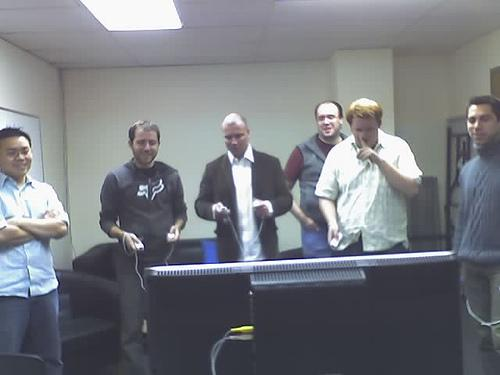Question: how many women are in the picture?
Choices:
A. None.
B. One.
C. Two.
D. Three.
Answer with the letter. Answer: A Question: what are the guys in the picture looking at?
Choices:
A. The women.
B. The food.
C. The TV screen.
D. The beer.
Answer with the letter. Answer: C Question: where was this picture taken?
Choices:
A. A pool hall.
B. On a back porch.
C. On a deck.
D. An indoor room.
Answer with the letter. Answer: D Question: why are they smiling?
Choices:
A. They are telling jokes.
B. They are jumping on a trampoline.
C. They are playing a game.
D. They are playing tag.
Answer with the letter. Answer: C Question: how many people are in the picture?
Choices:
A. Six.
B. Five.
C. Four.
D. Three.
Answer with the letter. Answer: A Question: who is playing?
Choices:
A. Brothers holding remotes.
B. The two guys holding the remotes.
C. Boys holding controllers.
D. A father and son holding controllers.
Answer with the letter. Answer: B 